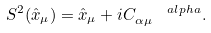<formula> <loc_0><loc_0><loc_500><loc_500>S ^ { 2 } ( \hat { x } _ { \mu } ) = \hat { x } _ { \mu } + i C _ { \alpha \mu } ^ { \quad a l p h a } .</formula> 